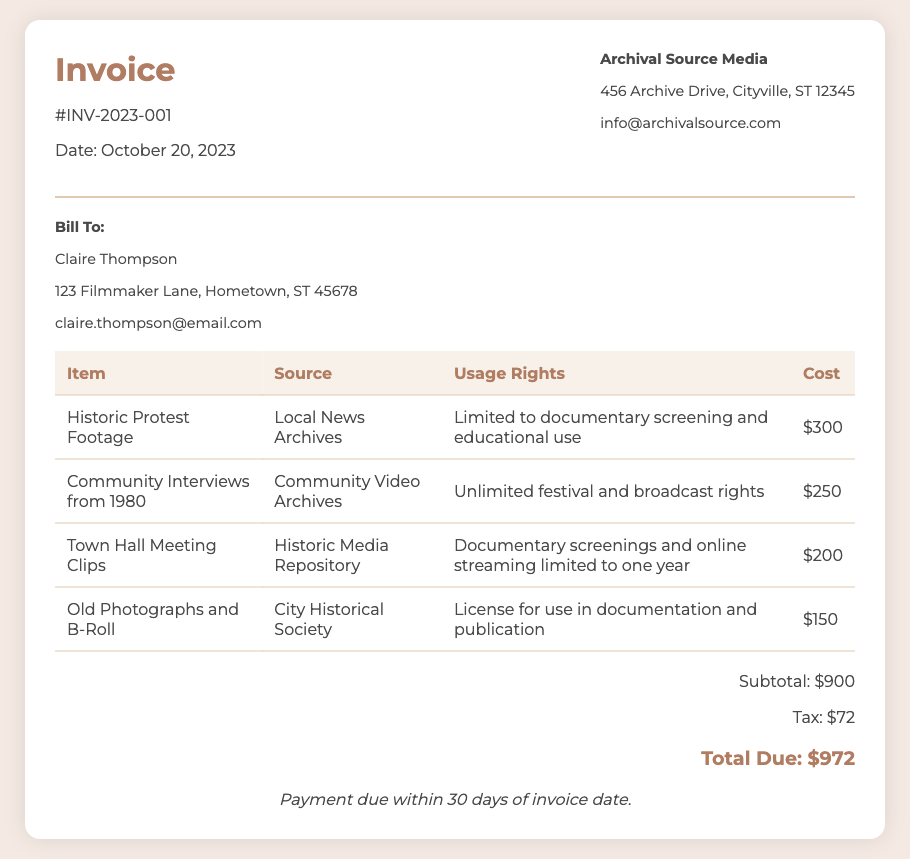What is the invoice number? The invoice number is listed at the top of the document, identified as #INV-2023-001.
Answer: #INV-2023-001 What date was the invoice issued? The date of the invoice is shown under the invoice number as October 20, 2023.
Answer: October 20, 2023 Who is the seller? The seller information is provided in the header of the invoice as Archival Source Media.
Answer: Archival Source Media What is the subtotal amount? The subtotal is calculated from the itemized costs, shown in the totals section as $900.
Answer: $900 How much is the tax? The tax amount is displayed in the totals section of the invoice as $72.
Answer: $72 What is the total due? The total due amount combines the subtotal and tax, listed as $972 in the totals section.
Answer: $972 What are the usage rights for the Community Interviews from 1980? The usage rights are specified in the table under that item as Unlimited festival and broadcast rights.
Answer: Unlimited festival and broadcast rights Which source charges the highest cost? By comparing the costs in the table, the item from Local News Archives has the highest charge of $300.
Answer: Local News Archives How long is the license for Town Hall Meeting Clips limited to? The document specifies that the usage is limited to one year for the Town Hall Meeting Clips.
Answer: one year 